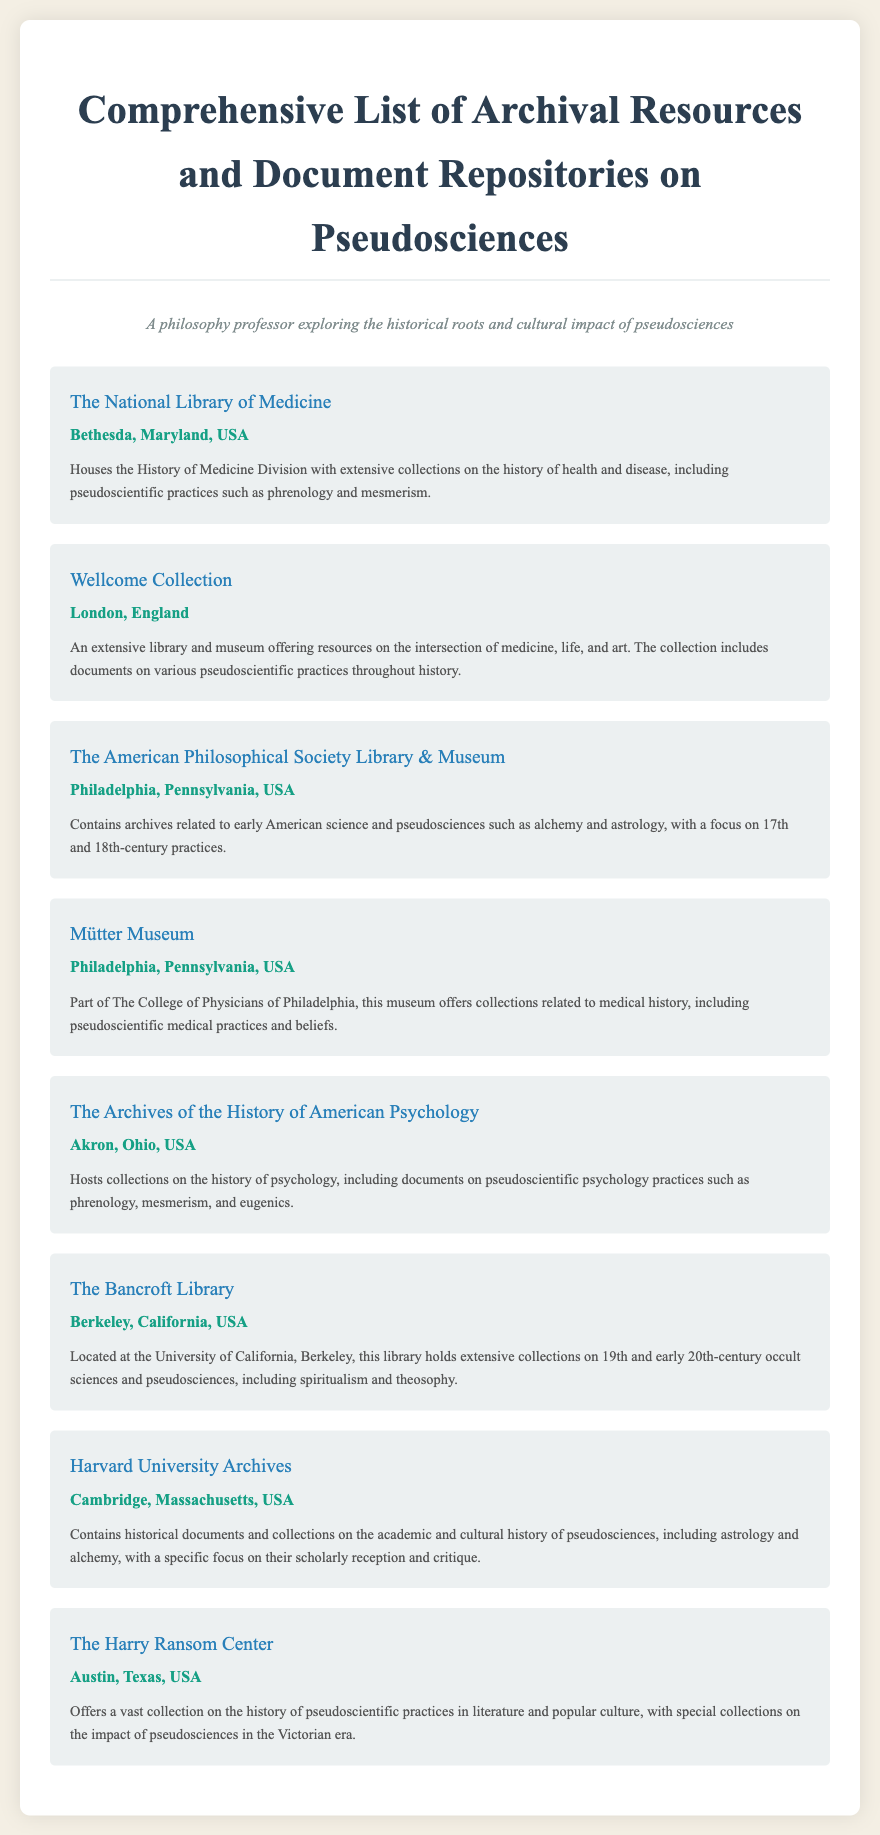what is the title of the document? The title of the document is the main heading, which is shown prominently at the top.
Answer: Comprehensive List of Archival Resources and Document Repositories on Pseudosciences where is the Wellcome Collection located? The location of the Wellcome Collection is specified in the document.
Answer: London, England which resource focuses on the history of American psychology? The document mentions several resources, and one specifically focuses on psychology.
Answer: The Archives of the History of American Psychology how many resources are listed in the document? The document lists various resources, and counting those gives the total amount.
Answer: Eight which archive contains collections related to phrenology and mesmerism? The document highlights specific collections that cover these pseudoscientific practices.
Answer: The National Library of Medicine what type of practices does the Mütter Museum's collection relate to? The document describes the nature of the collections present at the Mütter Museum.
Answer: pseudoscientific medical practices which library is part of the University of California? This is identified in the document, which lists libraries and their affiliations.
Answer: The Bancroft Library what is the focus of the resource at the Harry Ransom Center? The document describes the type of collection available at this center.
Answer: pseudoscientific practices in literature and popular culture 